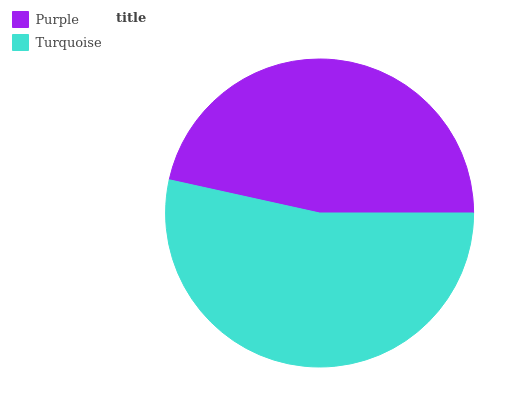Is Purple the minimum?
Answer yes or no. Yes. Is Turquoise the maximum?
Answer yes or no. Yes. Is Turquoise the minimum?
Answer yes or no. No. Is Turquoise greater than Purple?
Answer yes or no. Yes. Is Purple less than Turquoise?
Answer yes or no. Yes. Is Purple greater than Turquoise?
Answer yes or no. No. Is Turquoise less than Purple?
Answer yes or no. No. Is Turquoise the high median?
Answer yes or no. Yes. Is Purple the low median?
Answer yes or no. Yes. Is Purple the high median?
Answer yes or no. No. Is Turquoise the low median?
Answer yes or no. No. 